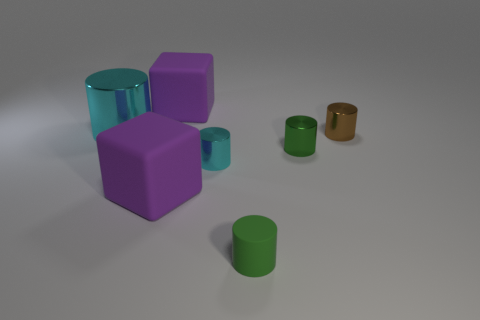Subtract all purple balls. How many green cylinders are left? 2 Subtract all brown cylinders. How many cylinders are left? 4 Add 3 cubes. How many objects exist? 10 Subtract all small brown metal cylinders. How many cylinders are left? 4 Subtract all purple cylinders. Subtract all green blocks. How many cylinders are left? 5 Add 7 cyan shiny things. How many cyan shiny things exist? 9 Subtract 0 blue cubes. How many objects are left? 7 Subtract all cylinders. How many objects are left? 2 Subtract all tiny brown things. Subtract all tiny brown things. How many objects are left? 5 Add 4 large cyan cylinders. How many large cyan cylinders are left? 5 